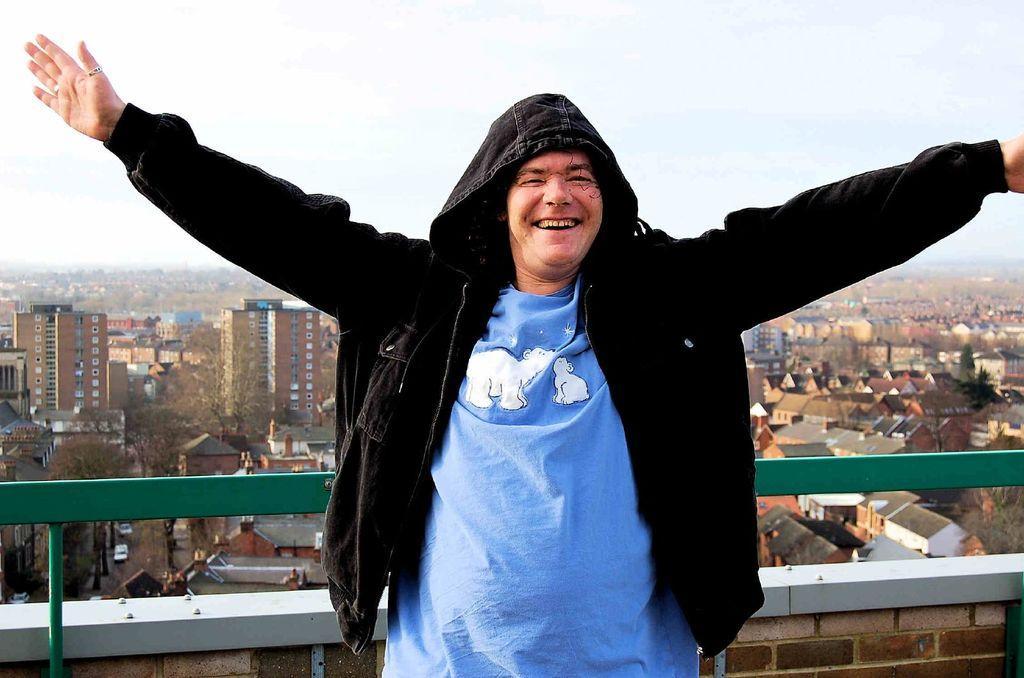How would you summarize this image in a sentence or two? In front of the image there is a person standing with a smile on his face, behind him there is a metal rod fence, behind the fence there are trees and buildings and vehicles on the road. 